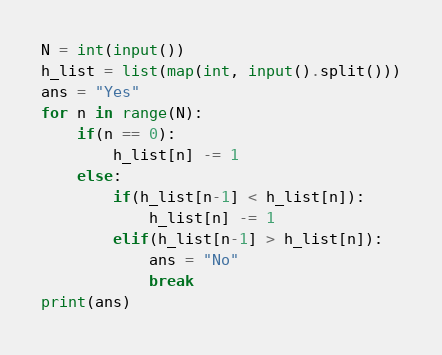<code> <loc_0><loc_0><loc_500><loc_500><_Python_>N = int(input())
h_list = list(map(int, input().split()))
ans = "Yes"
for n in range(N):
    if(n == 0):
        h_list[n] -= 1
    else:
        if(h_list[n-1] < h_list[n]):
            h_list[n] -= 1
        elif(h_list[n-1] > h_list[n]):
            ans = "No"
            break
print(ans)</code> 